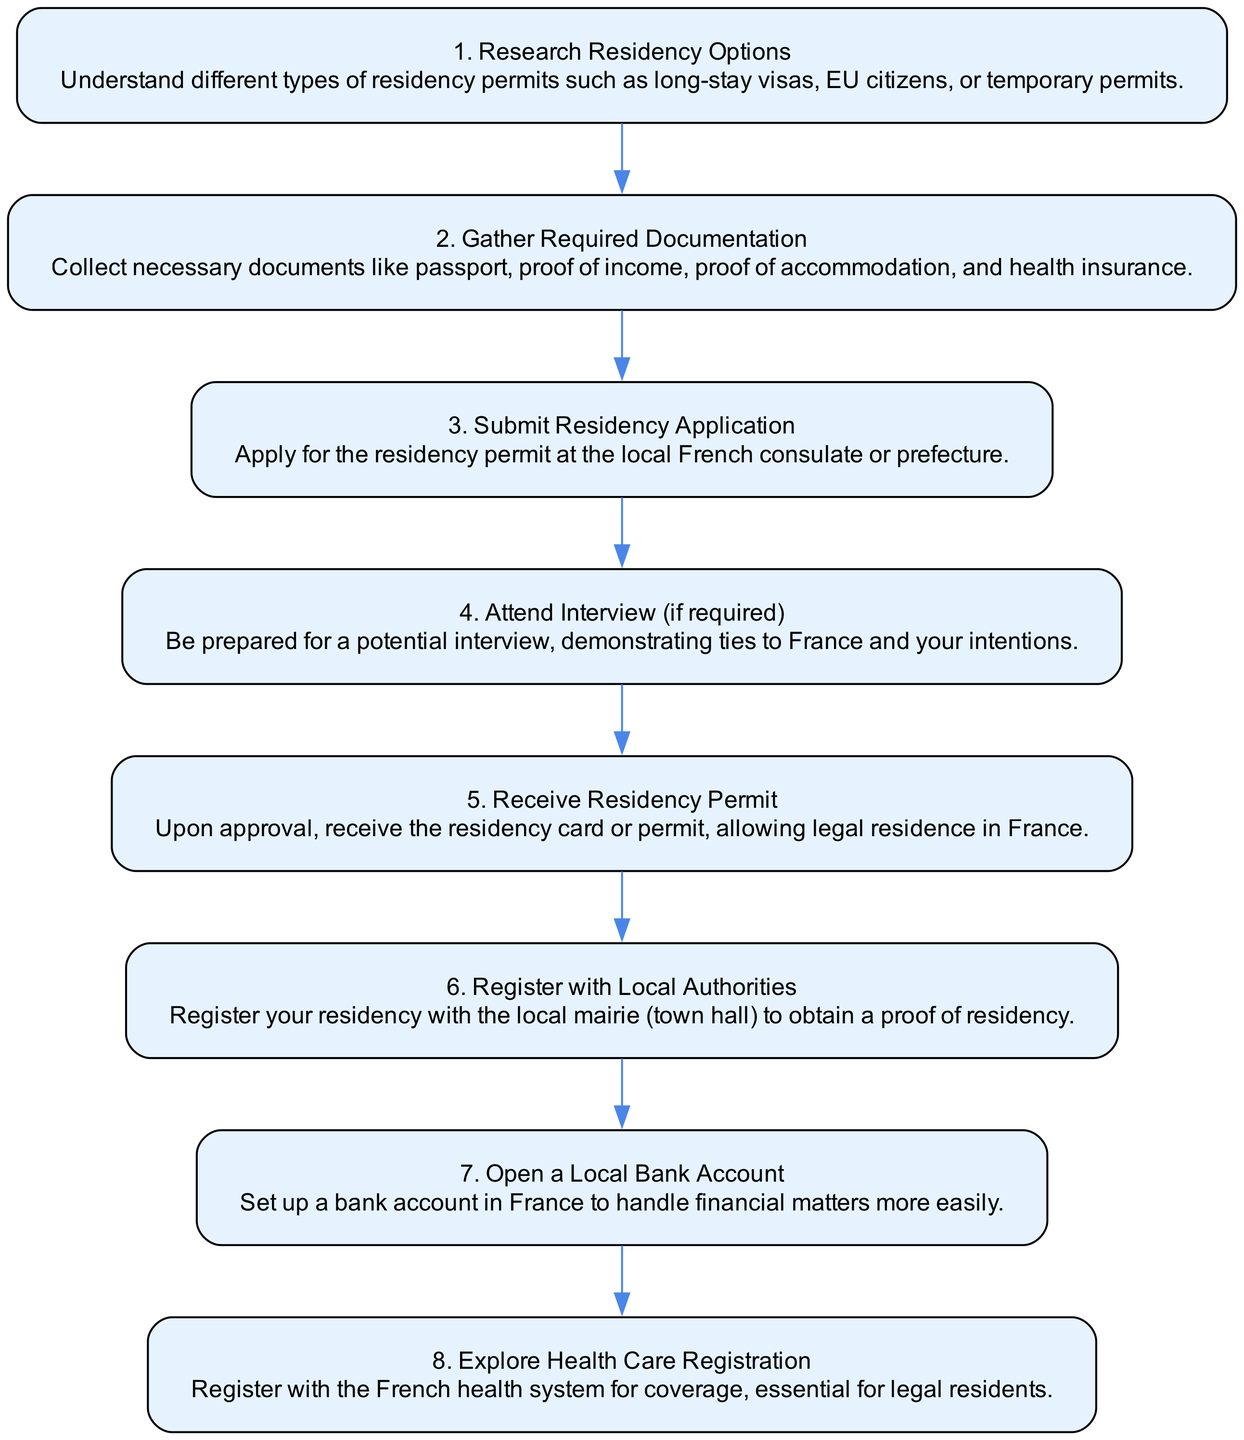What is the first step in establishing residency? The first step in the flow chart is "Research Residency Options," which indicates that the initial action required is to understand the different types of residency permits.
Answer: Research Residency Options How many steps are there in total? The diagram shows a total of 8 steps involved in establishing residency in France as an expat.
Answer: 8 What step follows "Submit Residency Application"? According to the flow chart, the step that follows "Submit Residency Application" is "Attend Interview (if required)," which suggests that there may be an interview after submitting the application.
Answer: Attend Interview (if required) What is required after receiving the residency permit? After receiving the residency permit, the next step is "Register with Local Authorities," which denotes the necessity of officially logging your residency.
Answer: Register with Local Authorities What is the last step in the process? The final step in establishing residency, according to the diagram, is "Explore Health Care Registration," indicating the necessity of registering for health care once residency is established.
Answer: Explore Health Care Registration Which step is concerned with financial matters? The step that addresses financial matters is "Open a Local Bank Account," as this step specifically mentions setting up a bank account for easier financial handling.
Answer: Open a Local Bank Account Where do you apply for the residency permit? The residency permit is applied for at the "local French consulate or prefecture," as indicated in the "Submit Residency Application" step.
Answer: local French consulate or prefecture What type of question is "What is the first step in establishing residency?" This question falls under the category of a descriptive question because it asks for specific information available prominently in the diagram.
Answer: descriptive question 